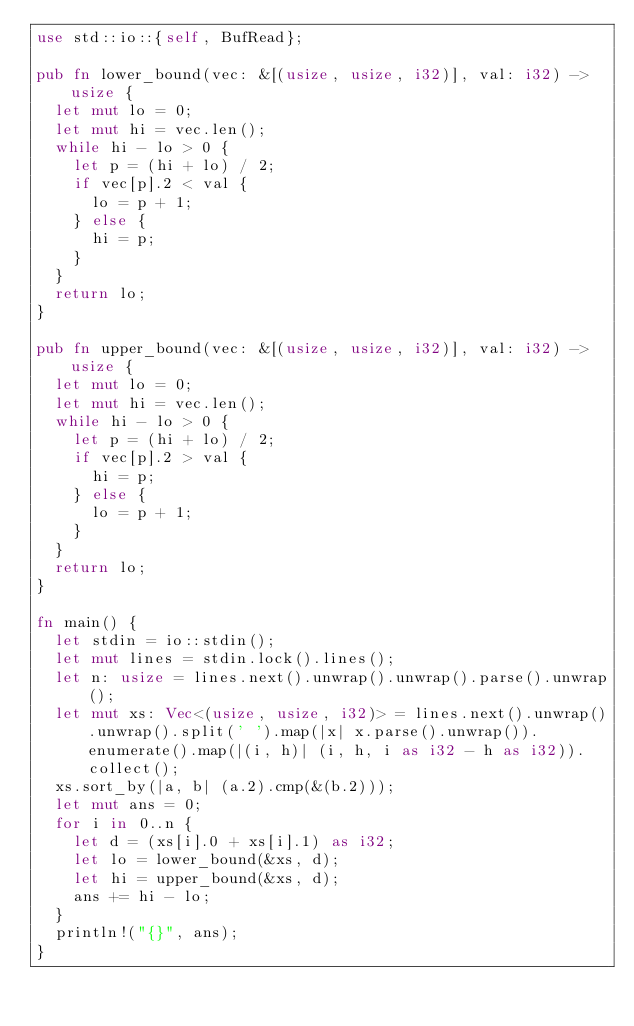Convert code to text. <code><loc_0><loc_0><loc_500><loc_500><_Rust_>use std::io::{self, BufRead};

pub fn lower_bound(vec: &[(usize, usize, i32)], val: i32) -> usize {
  let mut lo = 0;
  let mut hi = vec.len();
  while hi - lo > 0 {
    let p = (hi + lo) / 2;
    if vec[p].2 < val {
      lo = p + 1;
    } else {
      hi = p;
    }
  }
  return lo;
}

pub fn upper_bound(vec: &[(usize, usize, i32)], val: i32) -> usize {
  let mut lo = 0;
  let mut hi = vec.len();
  while hi - lo > 0 {
    let p = (hi + lo) / 2;
    if vec[p].2 > val {
      hi = p;
    } else {
      lo = p + 1;
    }
  }
  return lo;
}

fn main() {
  let stdin = io::stdin();
  let mut lines = stdin.lock().lines();
  let n: usize = lines.next().unwrap().unwrap().parse().unwrap();
  let mut xs: Vec<(usize, usize, i32)> = lines.next().unwrap().unwrap().split(' ').map(|x| x.parse().unwrap()).enumerate().map(|(i, h)| (i, h, i as i32 - h as i32)).collect();
  xs.sort_by(|a, b| (a.2).cmp(&(b.2)));
  let mut ans = 0;
  for i in 0..n {
    let d = (xs[i].0 + xs[i].1) as i32;
    let lo = lower_bound(&xs, d);
    let hi = upper_bound(&xs, d);
    ans += hi - lo;
  }
  println!("{}", ans);
}</code> 